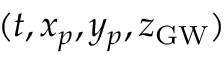<formula> <loc_0><loc_0><loc_500><loc_500>( t , x _ { p } , y _ { p } , z _ { G W } )</formula> 